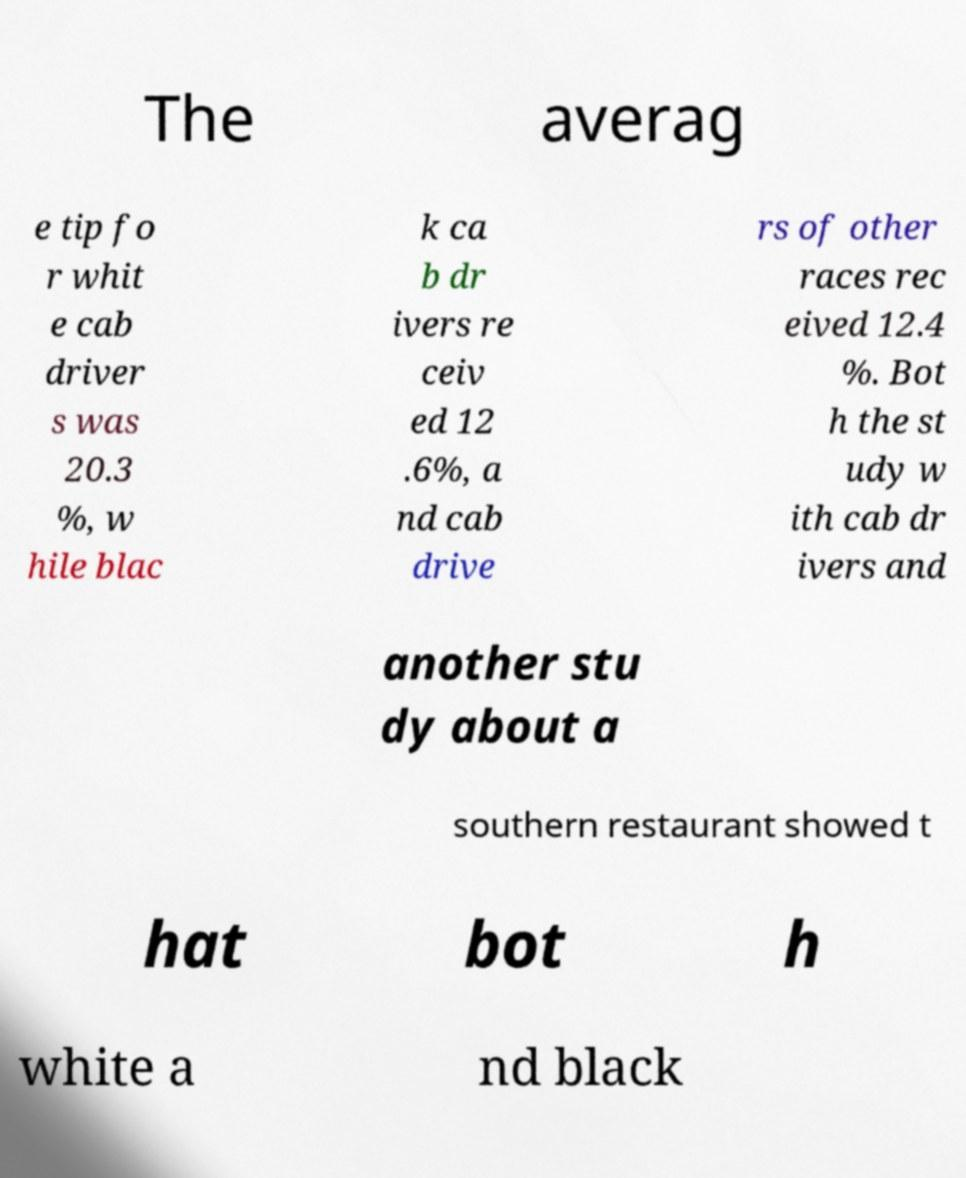Can you read and provide the text displayed in the image?This photo seems to have some interesting text. Can you extract and type it out for me? The averag e tip fo r whit e cab driver s was 20.3 %, w hile blac k ca b dr ivers re ceiv ed 12 .6%, a nd cab drive rs of other races rec eived 12.4 %. Bot h the st udy w ith cab dr ivers and another stu dy about a southern restaurant showed t hat bot h white a nd black 